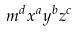<formula> <loc_0><loc_0><loc_500><loc_500>m ^ { d } x ^ { a } y ^ { b } z ^ { c }</formula> 